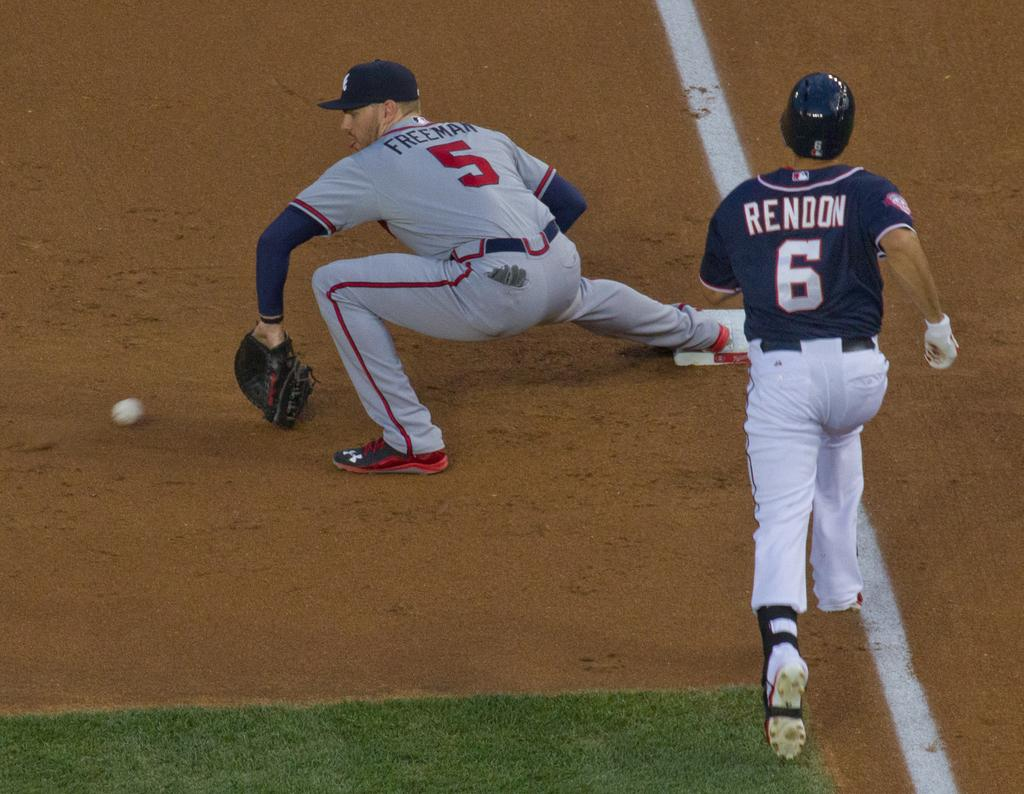<image>
Write a terse but informative summary of the picture. Rendon, wearing the number 6 jersey, is on the run. 